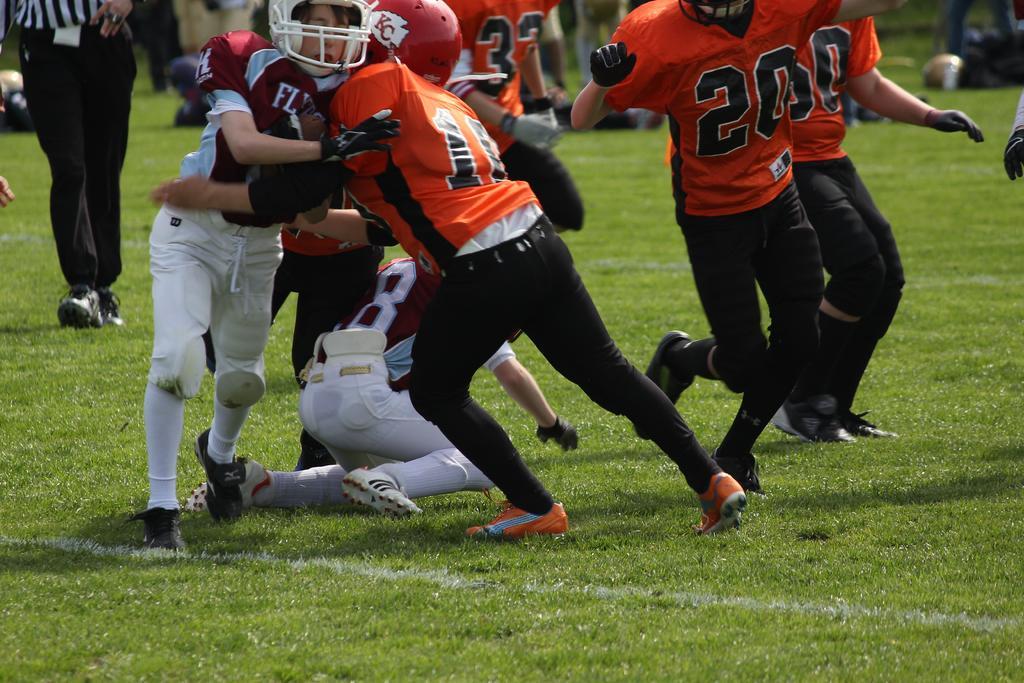Please provide a concise description of this image. In this image we can see a group of people on the ground. We can also see some grass. 